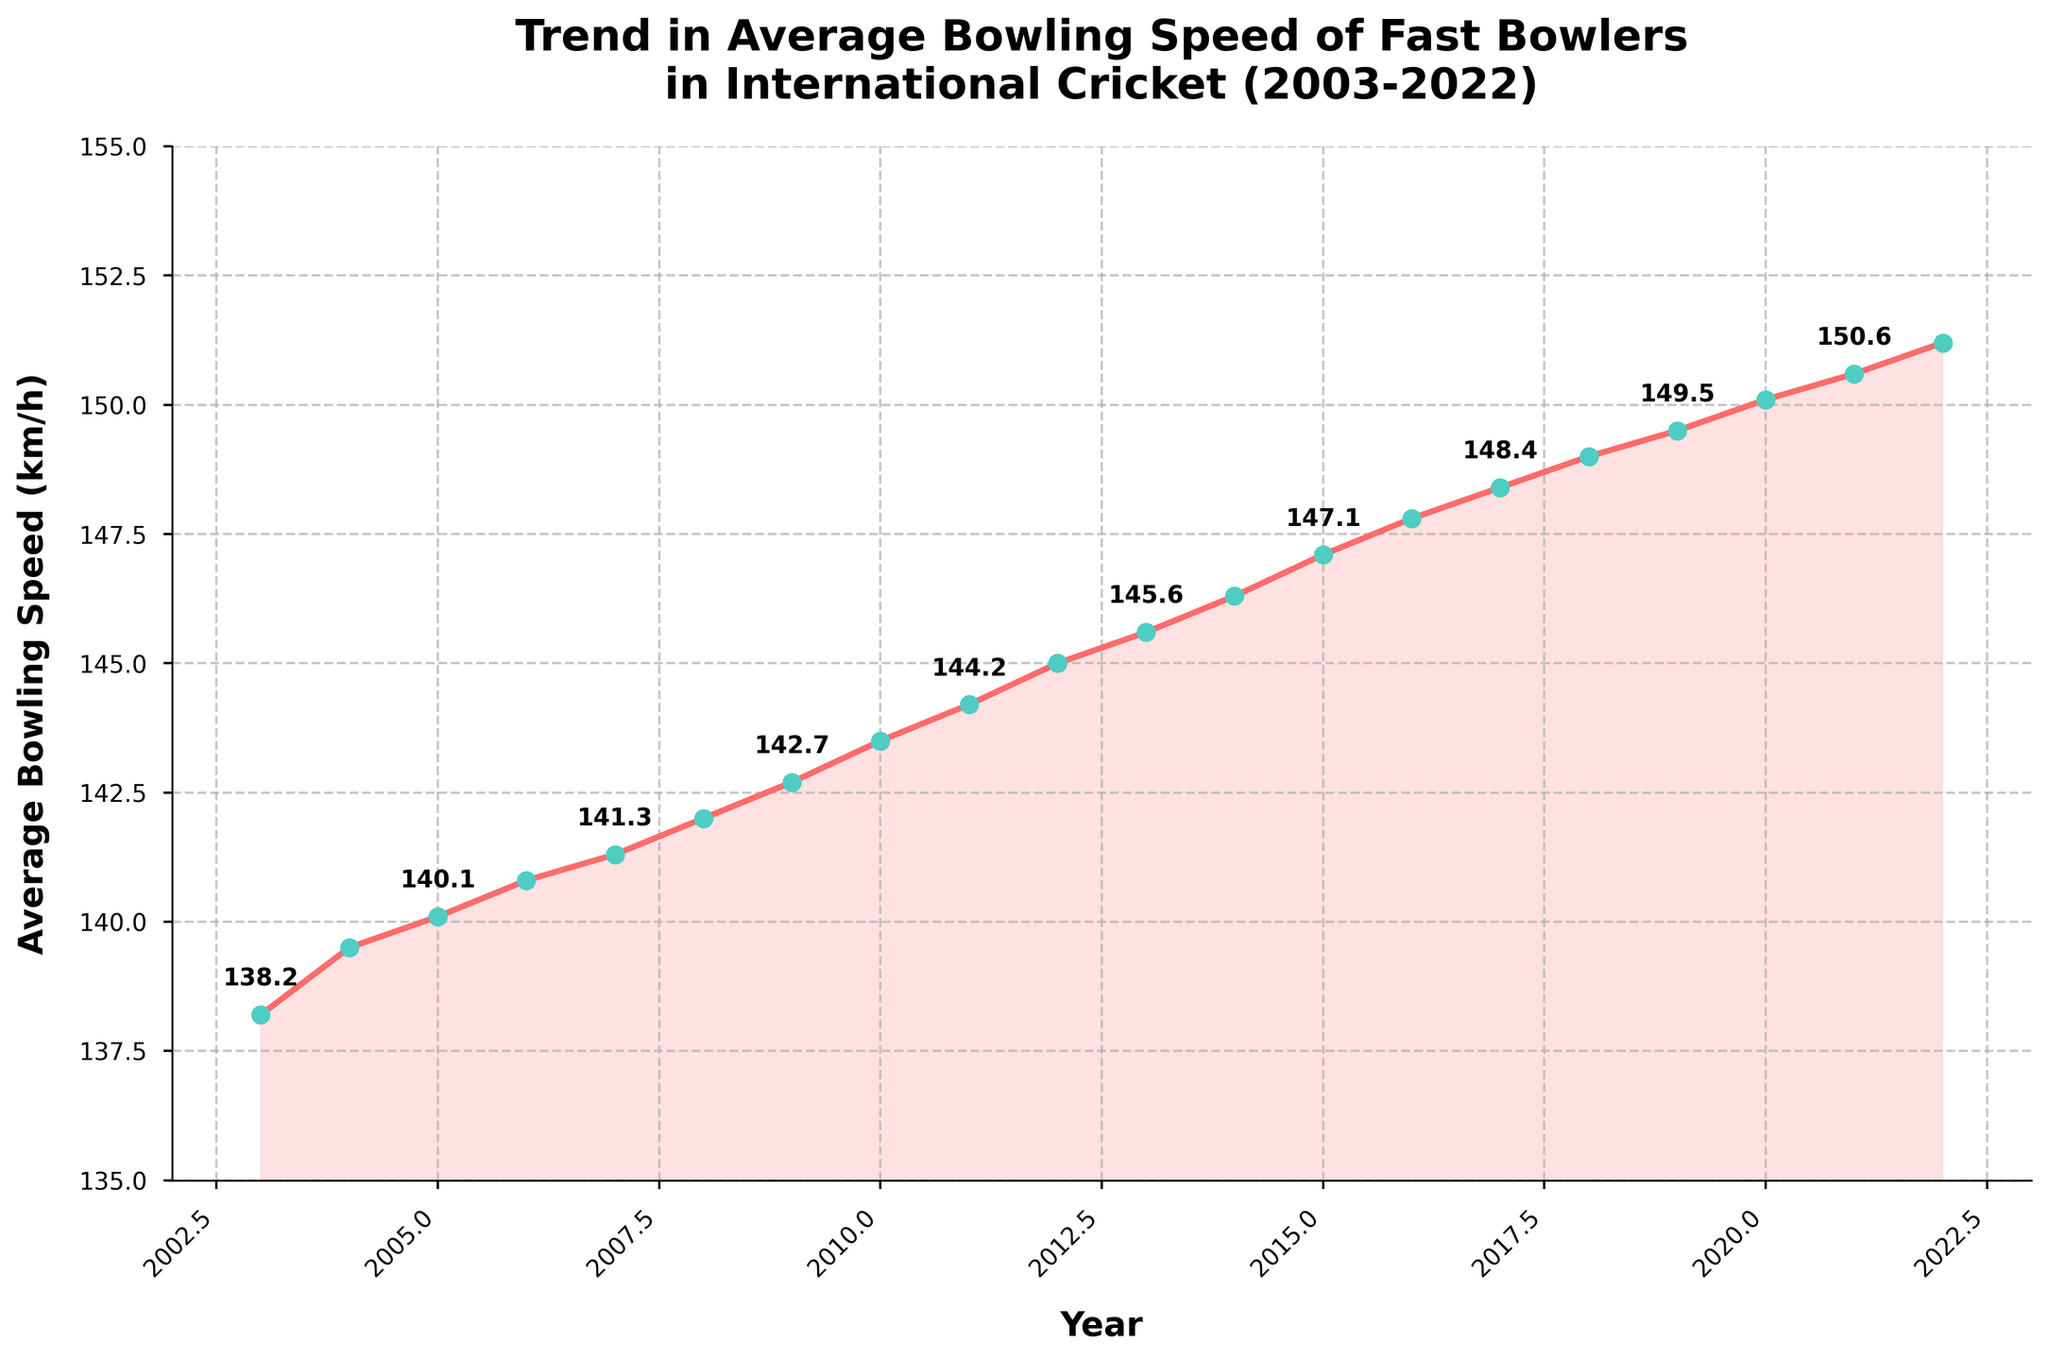What is the trend in the average bowling speed of fast bowlers from 2003 to 2022? The figure shows a line chart with an overall upward trend in average bowling speed from 2003 (138.2 km/h) to 2022 (151.2 km/h). This indicates that the average bowling speed of fast bowlers has been consistently increasing over the past 20 years.
Answer: Increasing What was the average bowling speed in 2010, and how does it compare to the average speed in 2003? The average bowling speed in 2010 was 143.5 km/h, while in 2003 it was 138.2 km/h. To compare, we calculate the difference: 143.5 - 138.2 = 5.3 km/h. Thus, the speed increased by 5.3 km/h from 2003 to 2010.
Answer: 143.5 km/h, 5.3 km/h increase In which year did the average bowling speed surpass 145 km/h for the first time? The figure shows that the average bowling speed surpassed 145 km/h for the first time in 2012, where the speed was 145.0 km/h.
Answer: 2012 How much did the average bowling speed increase from 2015 to 2022? The average bowling speed in 2015 was 147.1 km/h, and in 2022 it was 151.2 km/h. The increase is calculated by subtracting the 2015 value from the 2022 value: 151.2 - 147.1 = 4.1 km/h.
Answer: 4.1 km/h Identify the year with the largest single-year increase in average bowling speed and specify the values. The largest single-year increase occurred between 2014 and 2015. By comparing the speeds: 2014 (146.3 km/h) to 2015 (147.1 km/h), the increase is 147.1 - 146.3 = 0.8 km/h.
Answer: 2014 to 2015, 0.8 km/h Which year had the slowest average bowling speed, and what was the speed? The figure shows that the year with the slowest average bowling speed was 2003 with a speed of 138.2 km/h.
Answer: 2003, 138.2 km/h Describe the visual characteristics of the line chart and explain its trend. The line chart features a series of data points connected by a red line, with markers for each year. The markers are filled and outlined with different colors for easier visibility. The chart’s title and axis labels are bold. The line’s upward slope and the shaded region below it visually emphasize the increasing trend over the years.
Answer: Red line with markers, increasing trend What can be inferred about the physical fitness and strength of fast bowlers over the past two decades based on this chart? The consistent increase in average bowling speed over the past 20 years suggests improvements in the physical fitness, strength, and possibly training techniques of fast bowlers. Higher speeds typically indicate enhanced physical conditioning and better training methodologies.
Answer: Enhanced fitness and training By what amount did the average bowling speed change between the first and the last year shown on the graph? Between 2003 (138.2 km/h) and 2022 (151.2 km/h), the average bowling speed increased by 151.2 - 138.2 = 13 km/h.
Answer: 13 km/h How would you describe the increase in average bowling speed visually? Visually, the increase is depicted by an upward trending red line that gradually rises from left to right, with each successive marker positioned higher than the previous ones, indicating continuous growth over the years.
Answer: Gradual upward trend 